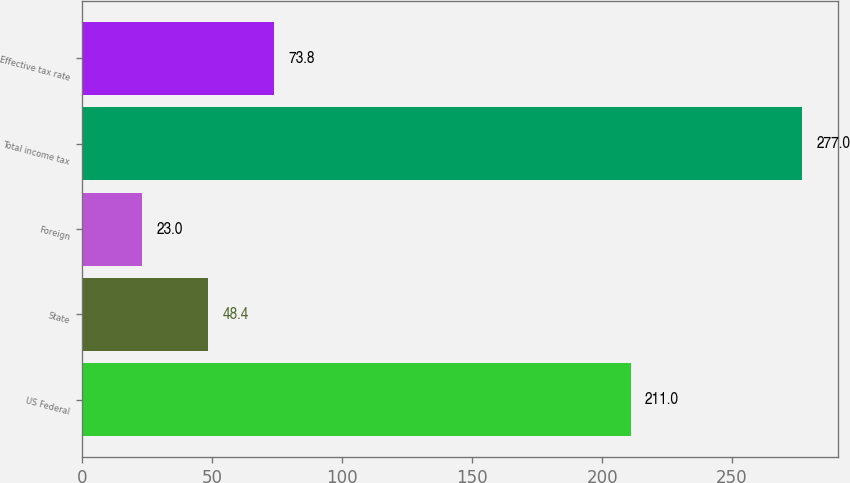Convert chart to OTSL. <chart><loc_0><loc_0><loc_500><loc_500><bar_chart><fcel>US Federal<fcel>State<fcel>Foreign<fcel>Total income tax<fcel>Effective tax rate<nl><fcel>211<fcel>48.4<fcel>23<fcel>277<fcel>73.8<nl></chart> 